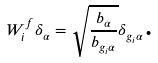<formula> <loc_0><loc_0><loc_500><loc_500>W _ { i } ^ { f } \delta _ { \alpha } = \sqrt { \frac { b _ { \alpha } } { b _ { g _ { i } \alpha } } } \delta _ { g _ { i } \alpha } \text {.}</formula> 